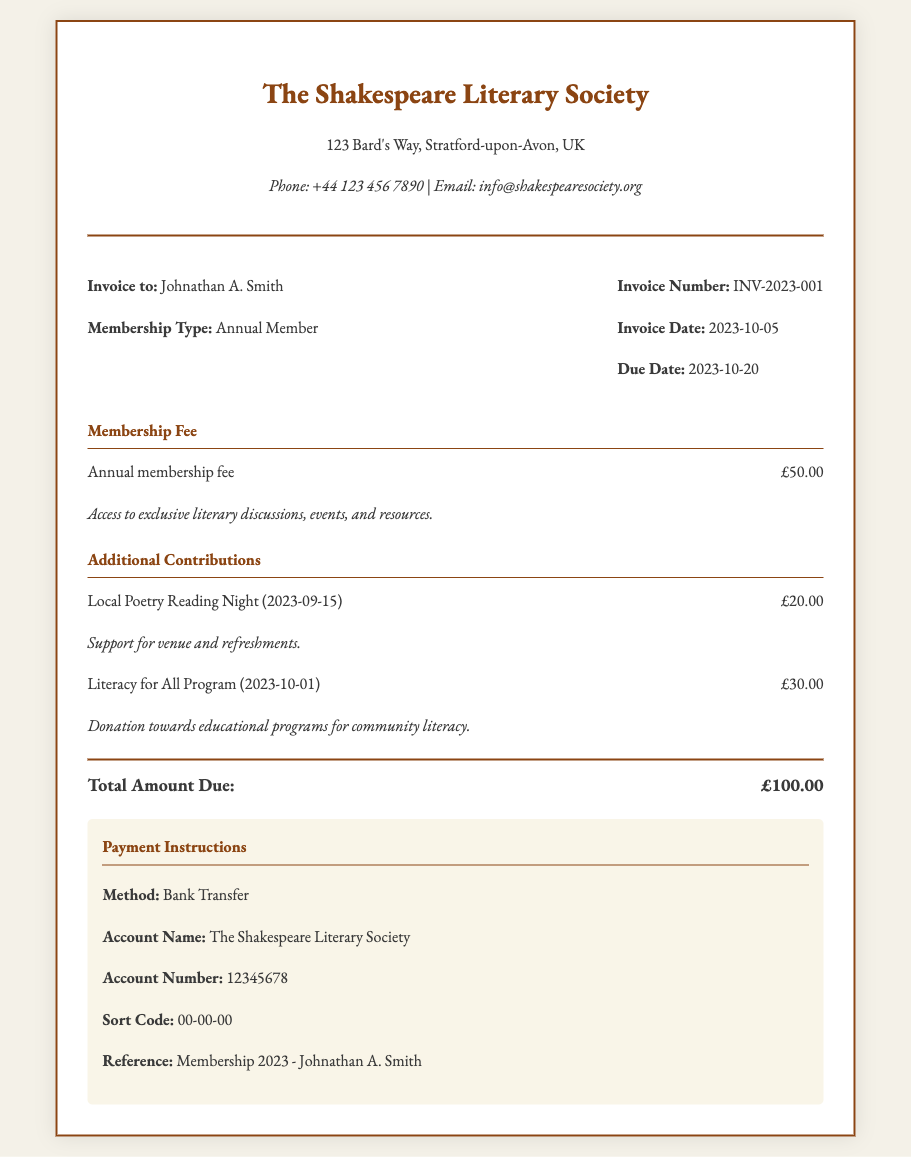what is the membership type? The membership type is specified in the invoice details, which indicates the member's category.
Answer: Annual Member what is the invoice number? The invoice number is a unique identifier for the document, noted for tracking purposes.
Answer: INV-2023-001 what is the total amount due? The total amount due is calculated from the membership fee and contributions listed in the invoice.
Answer: £100.00 who is the invoice addressed to? The name provided in the invoice details specifies the recipient of the invoice.
Answer: Johnathan A. Smith what is the due date for payment? The due date indicates when the payment needs to be made according to the invoice details.
Answer: 2023-10-20 list the contributions made for local events. The contributions include amounts allocated for specific events detailed in the invoice.
Answer: £20.00, £30.00 what is included in the membership fee? This part explains the benefits provided by paying the membership fee as mentioned in the document.
Answer: Access to exclusive literary discussions, events, and resources what is the method of payment? The invoice specifies the payment method to be used for settling the total amount.
Answer: Bank Transfer who to make the payment to? The account name provided indicates the organization benefiting from the payment.
Answer: The Shakespeare Literary Society 